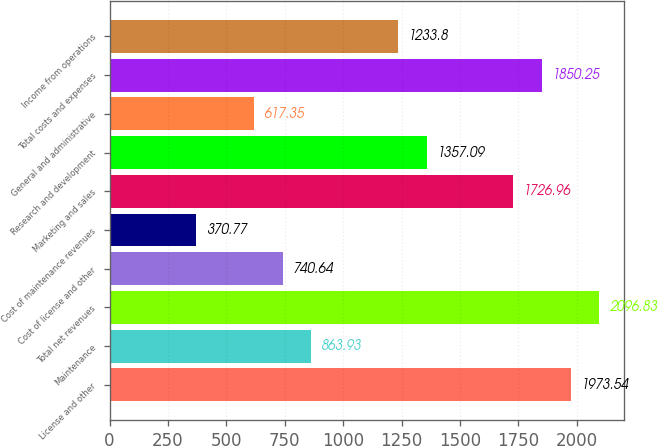<chart> <loc_0><loc_0><loc_500><loc_500><bar_chart><fcel>License and other<fcel>Maintenance<fcel>Total net revenues<fcel>Cost of license and other<fcel>Cost of maintenance revenues<fcel>Marketing and sales<fcel>Research and development<fcel>General and administrative<fcel>Total costs and expenses<fcel>Income from operations<nl><fcel>1973.54<fcel>863.93<fcel>2096.83<fcel>740.64<fcel>370.77<fcel>1726.96<fcel>1357.09<fcel>617.35<fcel>1850.25<fcel>1233.8<nl></chart> 